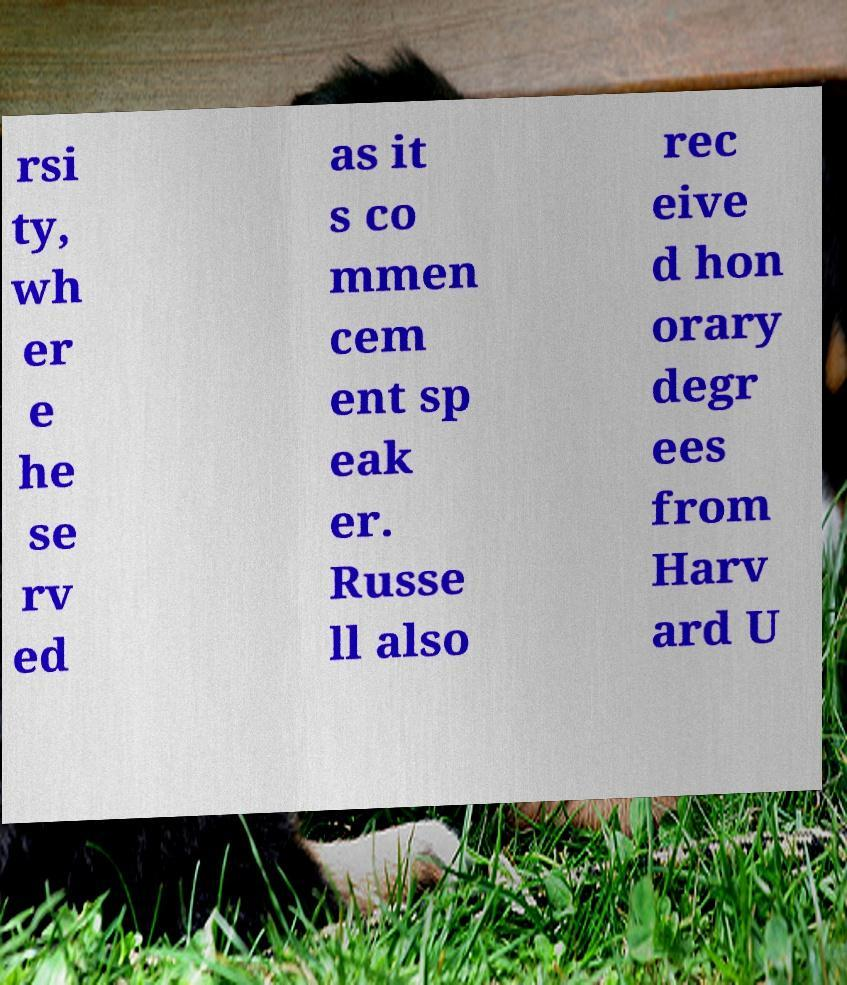I need the written content from this picture converted into text. Can you do that? rsi ty, wh er e he se rv ed as it s co mmen cem ent sp eak er. Russe ll also rec eive d hon orary degr ees from Harv ard U 